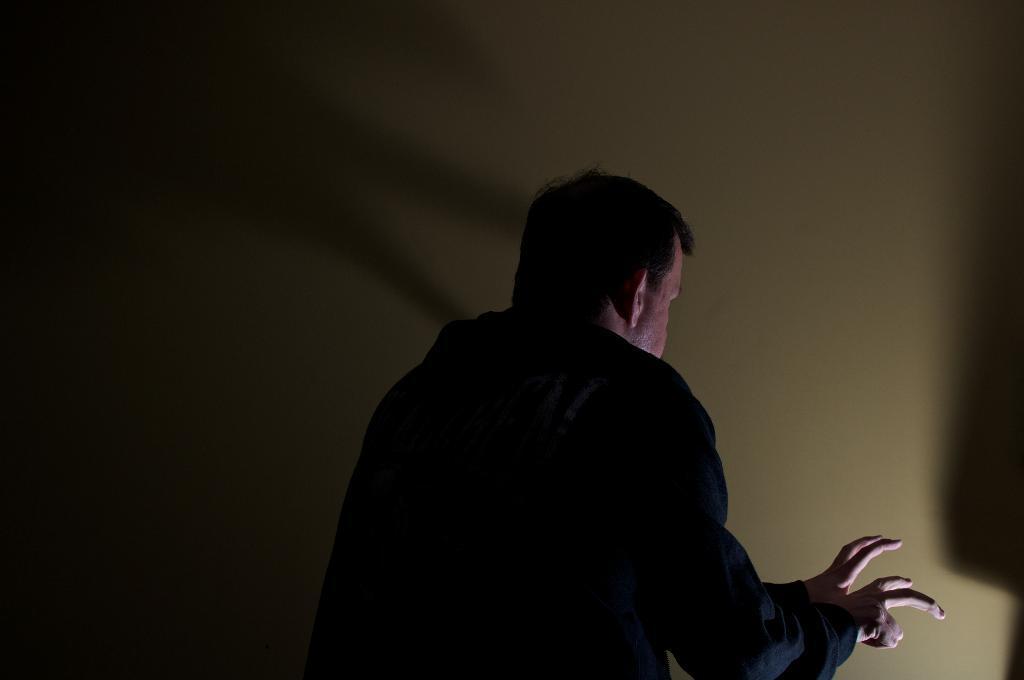In one or two sentences, can you explain what this image depicts? In this image I can see the person with black color dress. In-front of the person I can see the wall which is in cream color. 